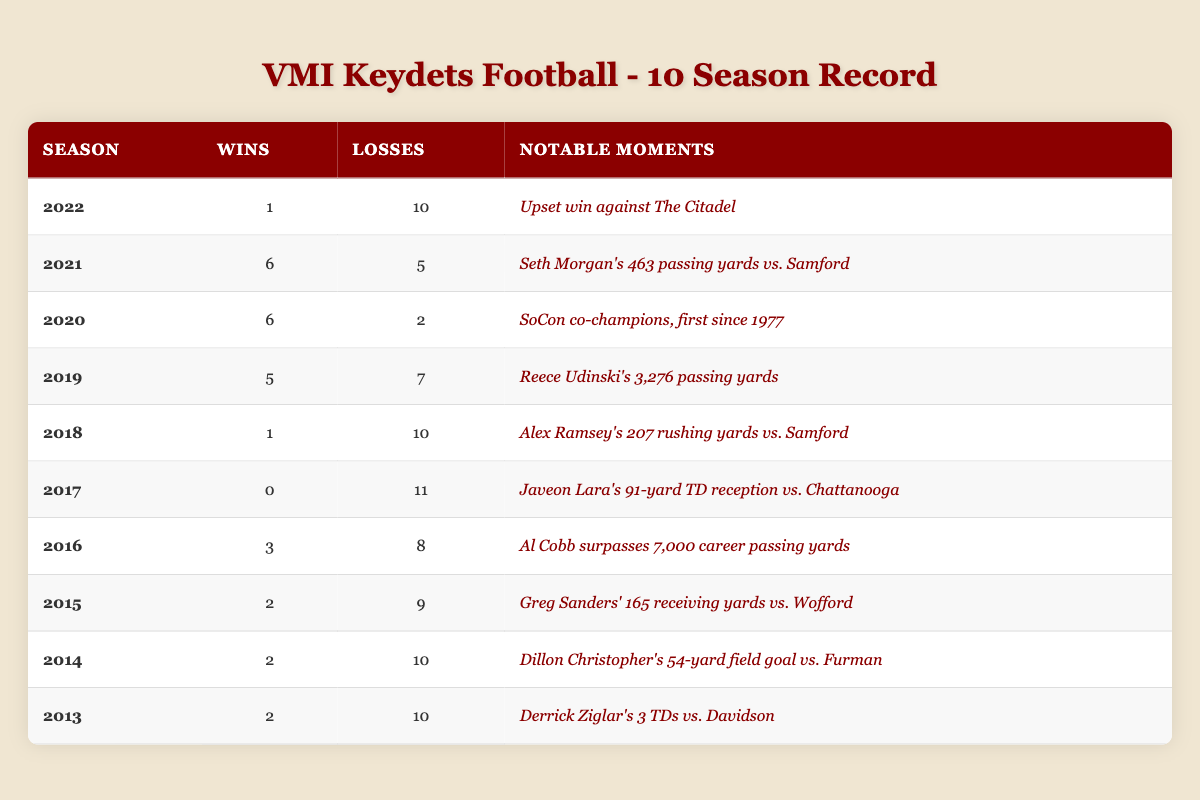What was the win-loss record for the VMI Keydets in 2022? In 2022, the table shows that the VMI Keydets had 1 win and 10 losses.
Answer: 1 win, 10 losses Which season had the most wins? The table highlights that 2021 had the most wins with 6, compared to other seasons.
Answer: 2021 What is the total number of wins over the last 10 seasons? By adding the wins from each season: 1 + 6 + 6 + 5 + 1 + 0 + 3 + 2 + 2 + 2 = 28. Therefore, the total number of wins is 28.
Answer: 28 Did the VMI Keydets achieve a winning season in any of the past ten years? A winning season is defined as having more wins than losses. Upon reviewing the table, only the 2021 season has 6 wins and 5 losses, indicating it was the only winning season.
Answer: No, only 2021 was a winning season What notable moment occurred for the VMI Keydets in 2020? According to the table, it states that VMI was SoCon co-champions, which was the first time since 1977, marking a significant achievement for that season.
Answer: SoCon co-champions, first since 1977 What is the average number of losses per season across the 10 seasons? To find the average, we first sum the losses: 10 + 5 + 2 + 7 + 10 + 11 + 8 + 9 + 10 + 10 = 88 total losses. Then, we divide this by the number of seasons (10): 88 / 10 = 8.8. Hence, the average number of losses per season is 8.8.
Answer: 8.8 How many seasons did the VMI Keydets have only 1 win? By scanning the table, we find that both the 2022 and 2018 seasons had only 1 win. Therefore, there are 2 seasons with just 1 win.
Answer: 2 seasons Was there a season where the VMI Keydets had 11 losses? The table indicates that 2017 is the only season where the team had 11 losses, confirming that this statement is true.
Answer: Yes, in 2017 In what year did Reece Udinski achieve 3,276 passing yards? Referring to the table, it is noted that Reece Udinski's 3,276 passing yards occurred in the 2019 season.
Answer: 2019 